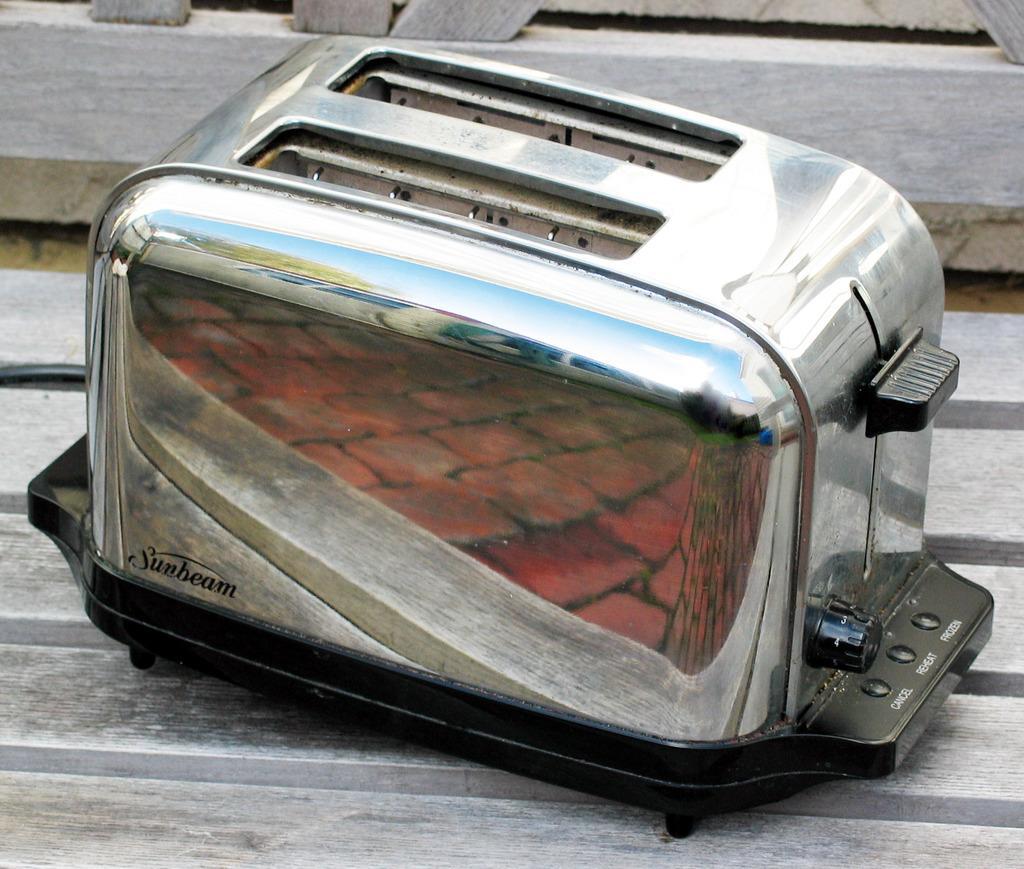In one or two sentences, can you explain what this image depicts? In this image I can see the silver and the black color object on the wooden surface. 